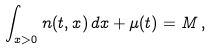<formula> <loc_0><loc_0><loc_500><loc_500>\int _ { x > 0 } n ( t , x ) \, d x + \mu ( t ) = M \, ,</formula> 